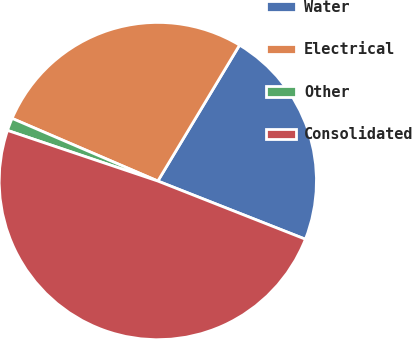Convert chart. <chart><loc_0><loc_0><loc_500><loc_500><pie_chart><fcel>Water<fcel>Electrical<fcel>Other<fcel>Consolidated<nl><fcel>22.36%<fcel>27.15%<fcel>1.29%<fcel>49.19%<nl></chart> 